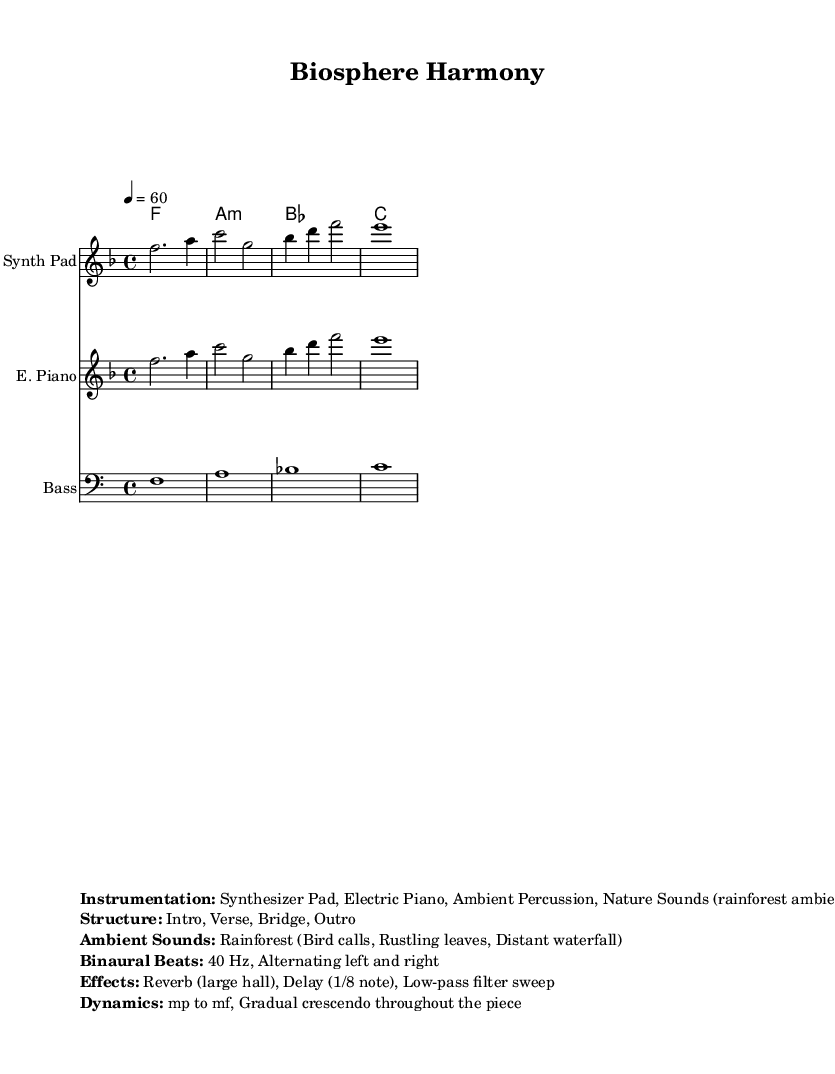What is the key signature of this music? The key signature is F major, which has one flat (B flat).
Answer: F major What is the time signature of this music? The time signature is 4/4, indicating four beats per measure.
Answer: 4/4 What is the tempo marking for this piece? The tempo marking is quarter note equals 60 beats per minute.
Answer: 60 What instruments are used in this composition? The listed instruments are a Synth Pad, Electric Piano, and Bass.
Answer: Synth Pad, Electric Piano, Bass How many sections are in the structure of the piece? The structure includes four sections: Intro, Verse, Bridge, and Outro.
Answer: Four What kind of ambient sounds are incorporated in the music? The ambient sounds consist of rainforest sounds including bird calls, rustling leaves, and a distant waterfall.
Answer: Rainforest (Bird calls, Rustling leaves, Distant waterfall) What frequency of binaural beats is used for focus in this piece? The binaural beats used are at 40 Hz, alternating between left and right channels.
Answer: 40 Hz 